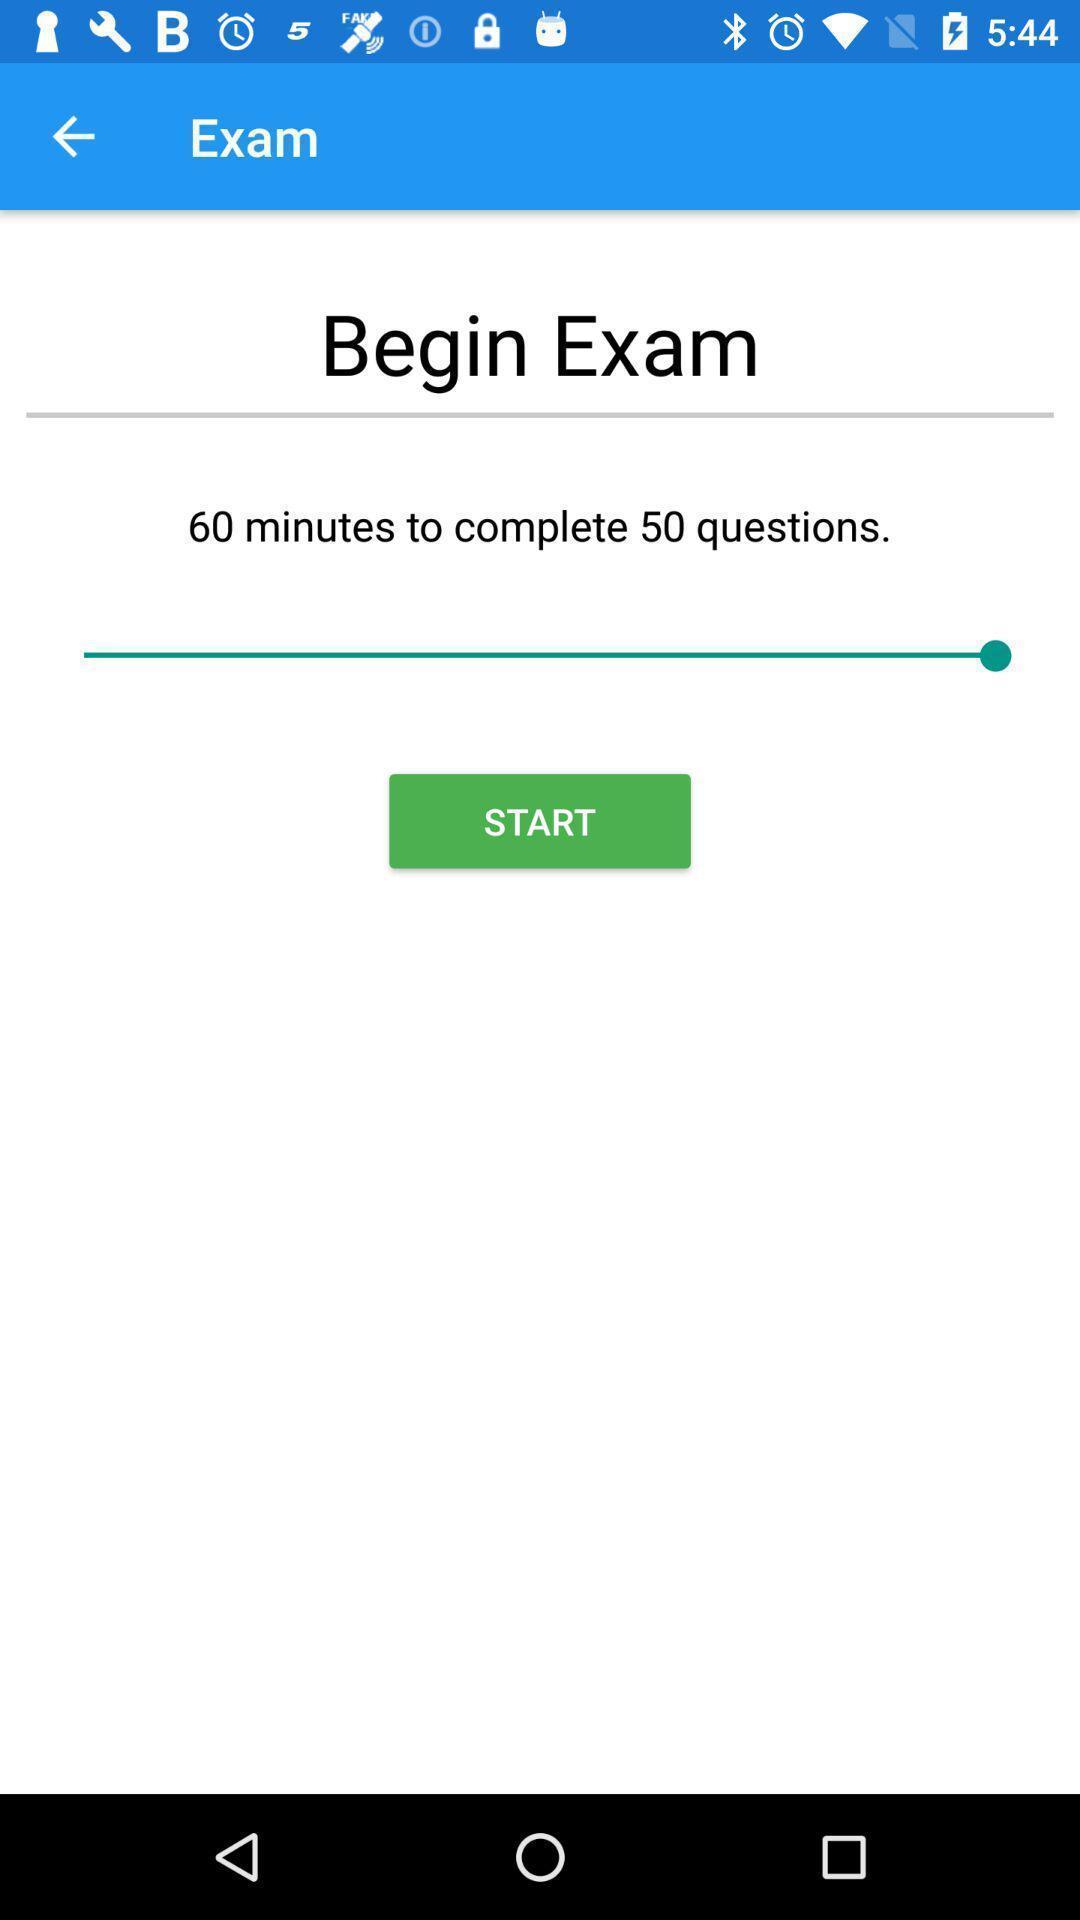Provide a description of this screenshot. Screen displaying the page of exam app. 